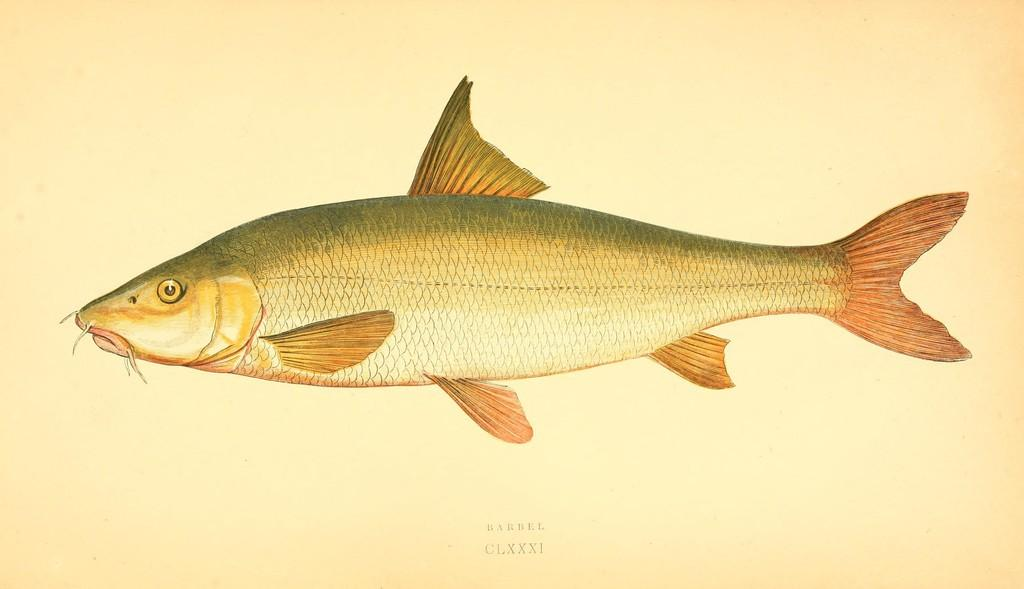What is present on the paper in the image? There are words and an image of a fish on the paper. Can you describe the image on the paper? The image on the paper is of a fish. What is the primary purpose of the paper in the image? The paper appears to be used for writing or drawing, as there are words on it. How many steps are required to reach the store from the location of the paper in the image? There is no store or indication of location in the image, so it is not possible to determine the number of steps required to reach a store. 